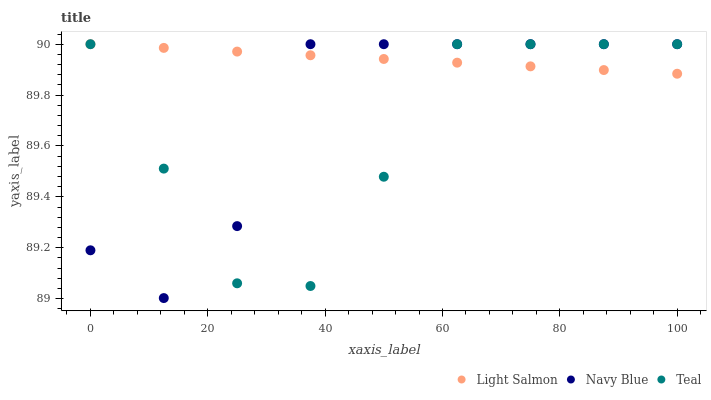Does Teal have the minimum area under the curve?
Answer yes or no. Yes. Does Light Salmon have the maximum area under the curve?
Answer yes or no. Yes. Does Light Salmon have the minimum area under the curve?
Answer yes or no. No. Does Teal have the maximum area under the curve?
Answer yes or no. No. Is Light Salmon the smoothest?
Answer yes or no. Yes. Is Navy Blue the roughest?
Answer yes or no. Yes. Is Teal the smoothest?
Answer yes or no. No. Is Teal the roughest?
Answer yes or no. No. Does Navy Blue have the lowest value?
Answer yes or no. Yes. Does Teal have the lowest value?
Answer yes or no. No. Does Teal have the highest value?
Answer yes or no. Yes. Does Navy Blue intersect Teal?
Answer yes or no. Yes. Is Navy Blue less than Teal?
Answer yes or no. No. Is Navy Blue greater than Teal?
Answer yes or no. No. 